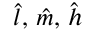<formula> <loc_0><loc_0><loc_500><loc_500>\hat { l } , \, \hat { m } , \, \hat { h }</formula> 